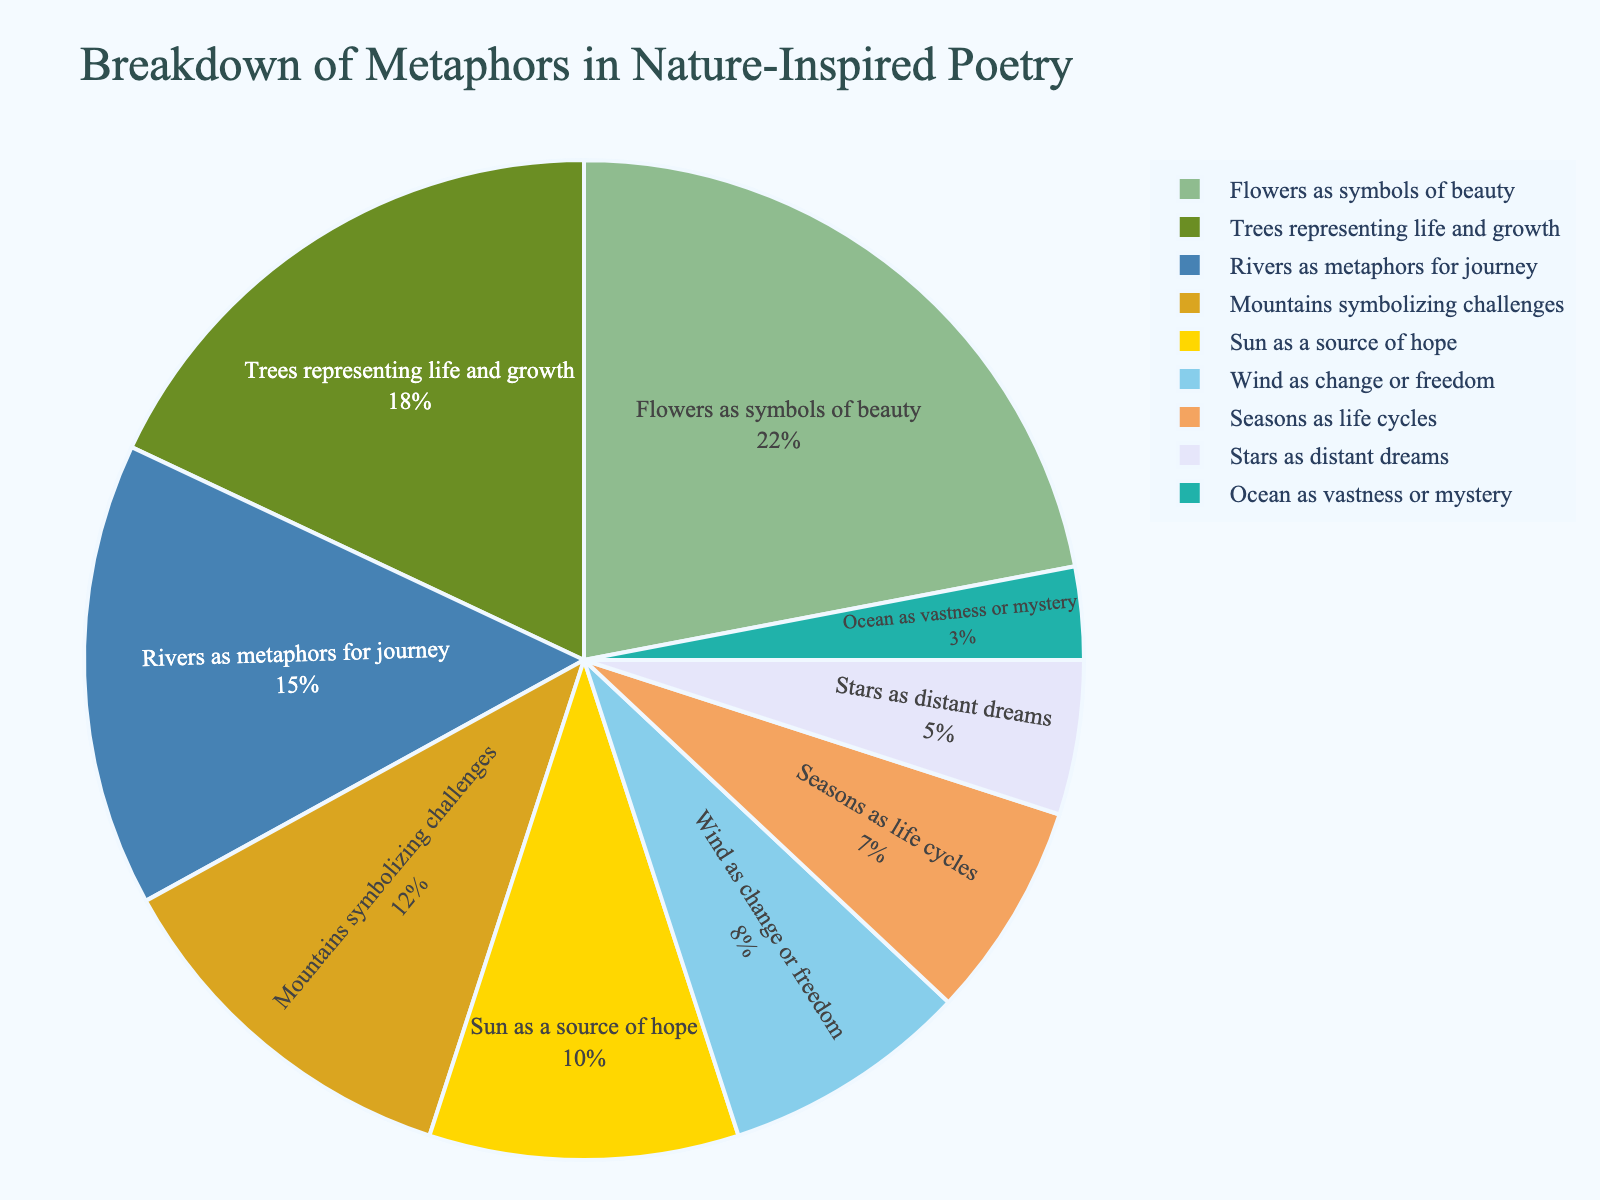What's the largest metaphor category in the pie chart? The largest section of the pie chart represents the metaphor "Flowers as symbols of beauty" with a percentage of 22%.
Answer: Flowers as symbols of beauty Which metaphor has the smallest representation in the pie chart? The smallest section of the pie chart is for "Ocean as vastness or mystery," which holds 3% of the total metaphors.
Answer: Ocean as vastness or mystery How much more common are metaphors related to flowers compared to seasons? The percentage for "Flowers as symbols of beauty" is 22%, while for "Seasons as life cycles," it is 7%. Subtracting these gives the difference as 22% - 7% = 15%. Thus, flower metaphors are 15% more common.
Answer: 15% What percentage of metaphors in the pie chart are related to trees and mountains combined? The percentage for "Trees representing life and growth" is 18%, and for "Mountains symbolizing challenges," it is 12%. Adding these together gives 18% + 12% = 30%.
Answer: 30% Is the percentage of metaphors using "Wind as change or freedom" greater than those using "Stars as distant dreams"? The percentage for "Wind as change or freedom" is 8%, which is greater than the 5% for "Stars as distant dreams."
Answer: Yes What is the total percentage of metaphors related to natural elements like flowers, trees, rivers, and mountains? Summing the percentages for "Flowers as symbols of beauty" (22%), "Trees representing life and growth" (18%), "Rivers as metaphors for journey" (15%), and "Mountains symbolizing challenges" (12%) gives 22% + 18% + 15% + 12% = 67%.
Answer: 67% Which metaphor types have percentages greater than 10%? The metaphor types with percentages greater than 10% are "Flowers as symbols of beauty" (22%), "Trees representing life and growth" (18%), "Rivers as metaphors for journey" (15%), and "Mountains symbolizing challenges" (12%).
Answer: Flowers as symbols of beauty, Trees representing life and growth, Rivers as metaphors for journey, Mountains symbolizing challenges By how much does the percentage of metaphors comparing the sun to a source of hope exceed those comparing seasons to life cycles? "Sun as a source of hope" has a percentage of 10%, while "Seasons as life cycles" has 7%. Subtracting these gives the difference as 10% - 7% = 3%.
Answer: 3% How do the visual sizes of sections indicate the predominant metaphor type? In a pie chart, the size of each section visually indicates its proportion relative to the whole. The section for "Flowers as symbols of beauty" is the largest, signifying it is the predominant metaphor type.
Answer: Largest section Which metaphor types occupy a similar portion of the chart based on visual comparison? "Wind as change or freedom" (8%) and "Seasons as life cycles" (7%) have visually similar sizes in the chart, indicating that they occupy comparable portions.
Answer: Wind as change or freedom, Seasons as life cycles 